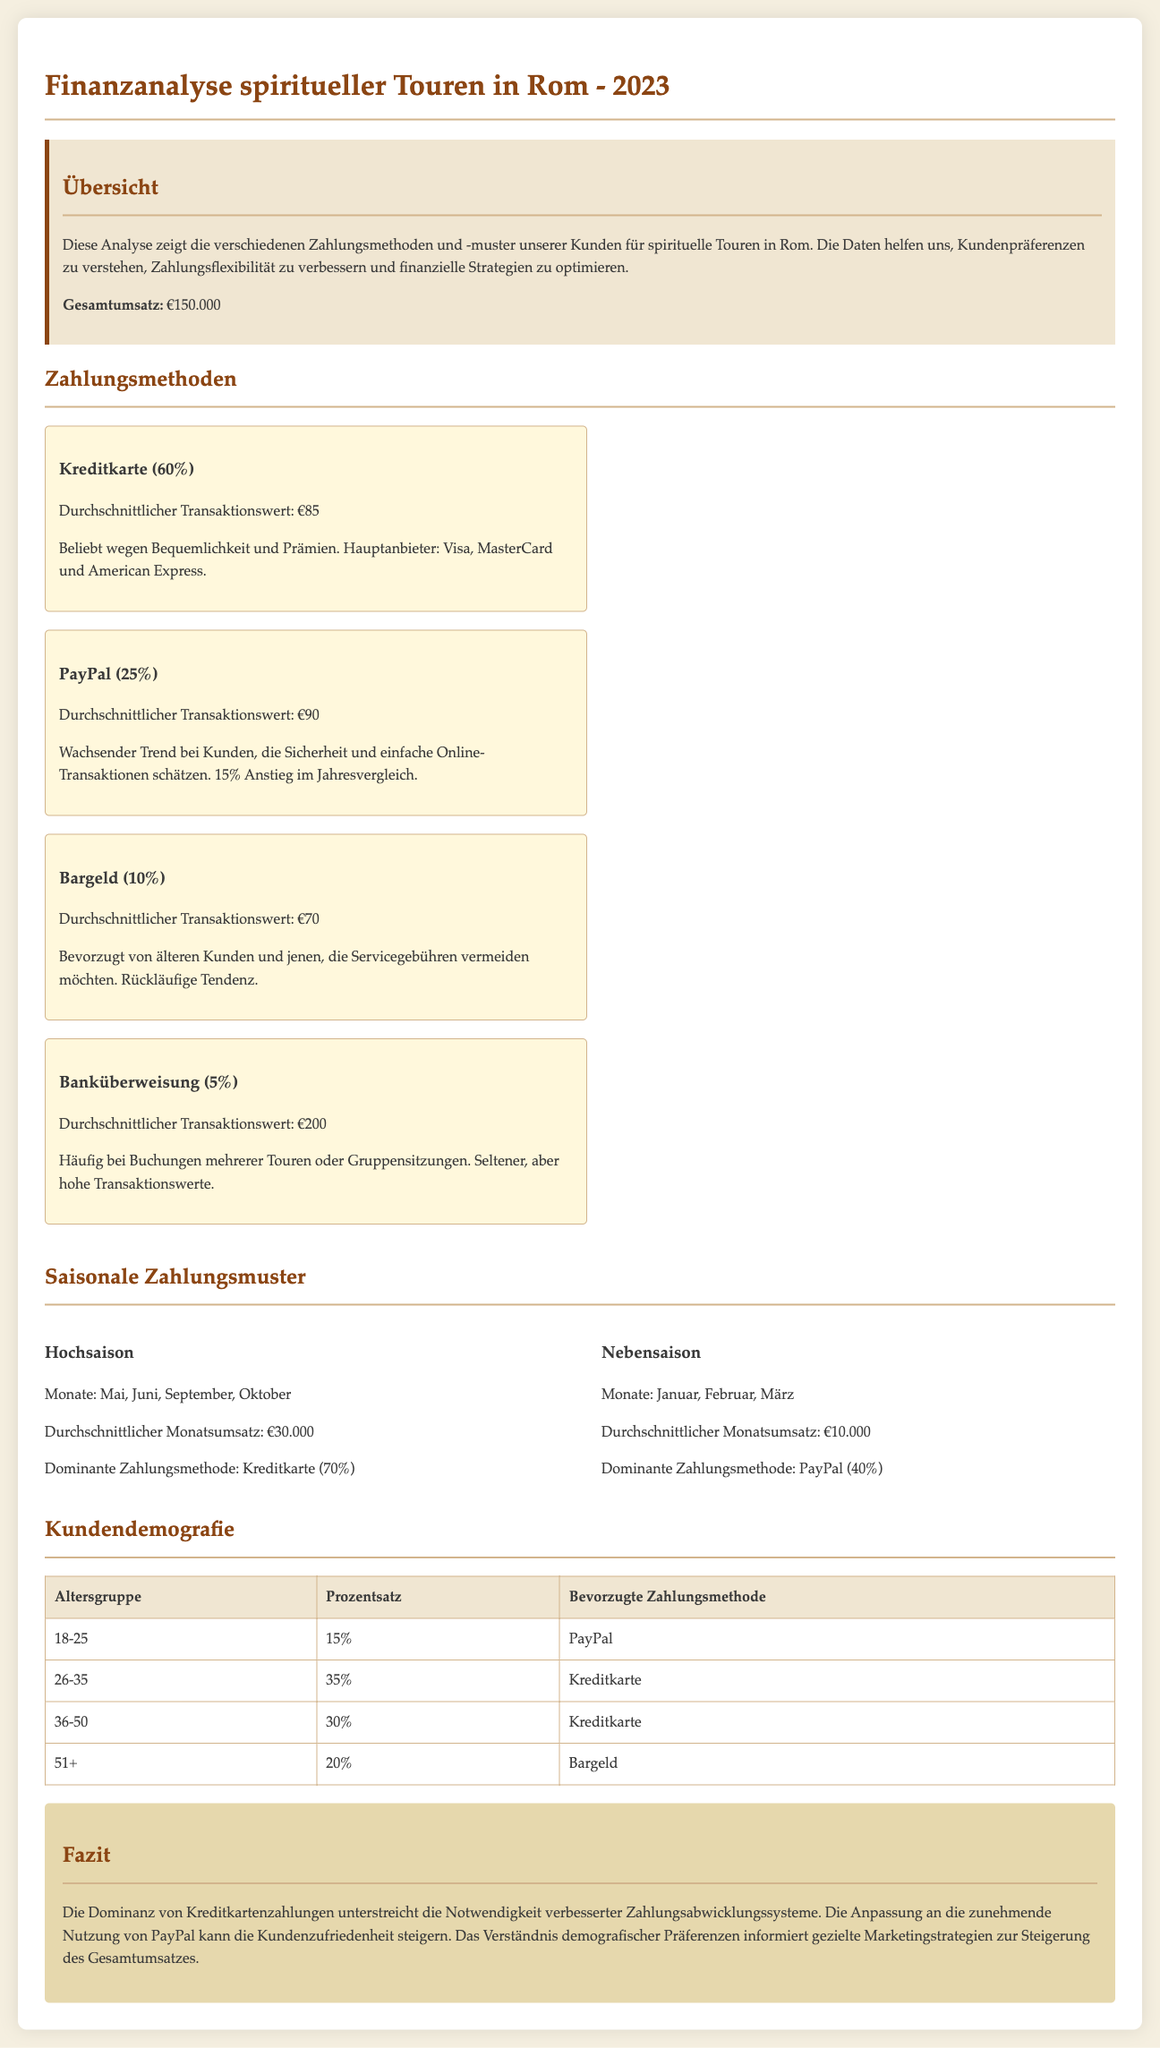Was ist der Gesamtumsatz? Der Gesamtumsatz ist in der Übersicht des Dokuments aufgeführt.
Answer: €150.000 Welche Zahlungsmethode hat den höchsten Anteil? Die Zahlungsmethode mit dem höchsten Anteil wird in der Kategorie Zahlungsmethoden genannt.
Answer: Kreditkarte (60%) Was ist der durchschnittliche Transaktionswert für PayPal? Der durchschnittliche Transaktionswert für PayPal ist im entsprechenden Zahlungsabschnitt aufgeführt.
Answer: €90 Welche Altersgruppe bevorzugt Bargeld? Die Altersgruppe, die Bargeld bevorzugt, wird in der Kundendemografie-Tabelle dargestellt.
Answer: 51+ In welchem Monat beginnt die Hochsaison? Die Monate, die zur Hochsaison gehören, werden im Abschnitt saisonale Zahlungsmuster aufgeführt.
Answer: Mai Welcher Prozentsatz der 36-50-Jährigen nutzt Kreditkarten? Der Prozentsatz der 36-50-Jährigen, die Kreditkarten nutzen, ist in der Kundendemografie-Tabelle angegeben.
Answer: 30% Wie hoch ist der durchschnittliche Monatsumsatz in der Nebensaison? Der durchschnittliche Monatsumsatz in der Nebensaison wird in der Rubrik saisonale Zahlungsmuster genannt.
Answer: €10.000 Was ist der Hauptgrund für die Nutzung von Bargeld? Die Begründung für die Nutzung von Bargeld wird im Abschnitt Zahlungsmethoden erklärt.
Answer: Servicegebühren vermeiden Welche Zahlungsmethode hat einen 15% Anstieg im Jahresvergleich? Der Anstieg dieser Zahlungsmethode wird im Abschnitt Zahlungsmethoden angegeben.
Answer: PayPal 